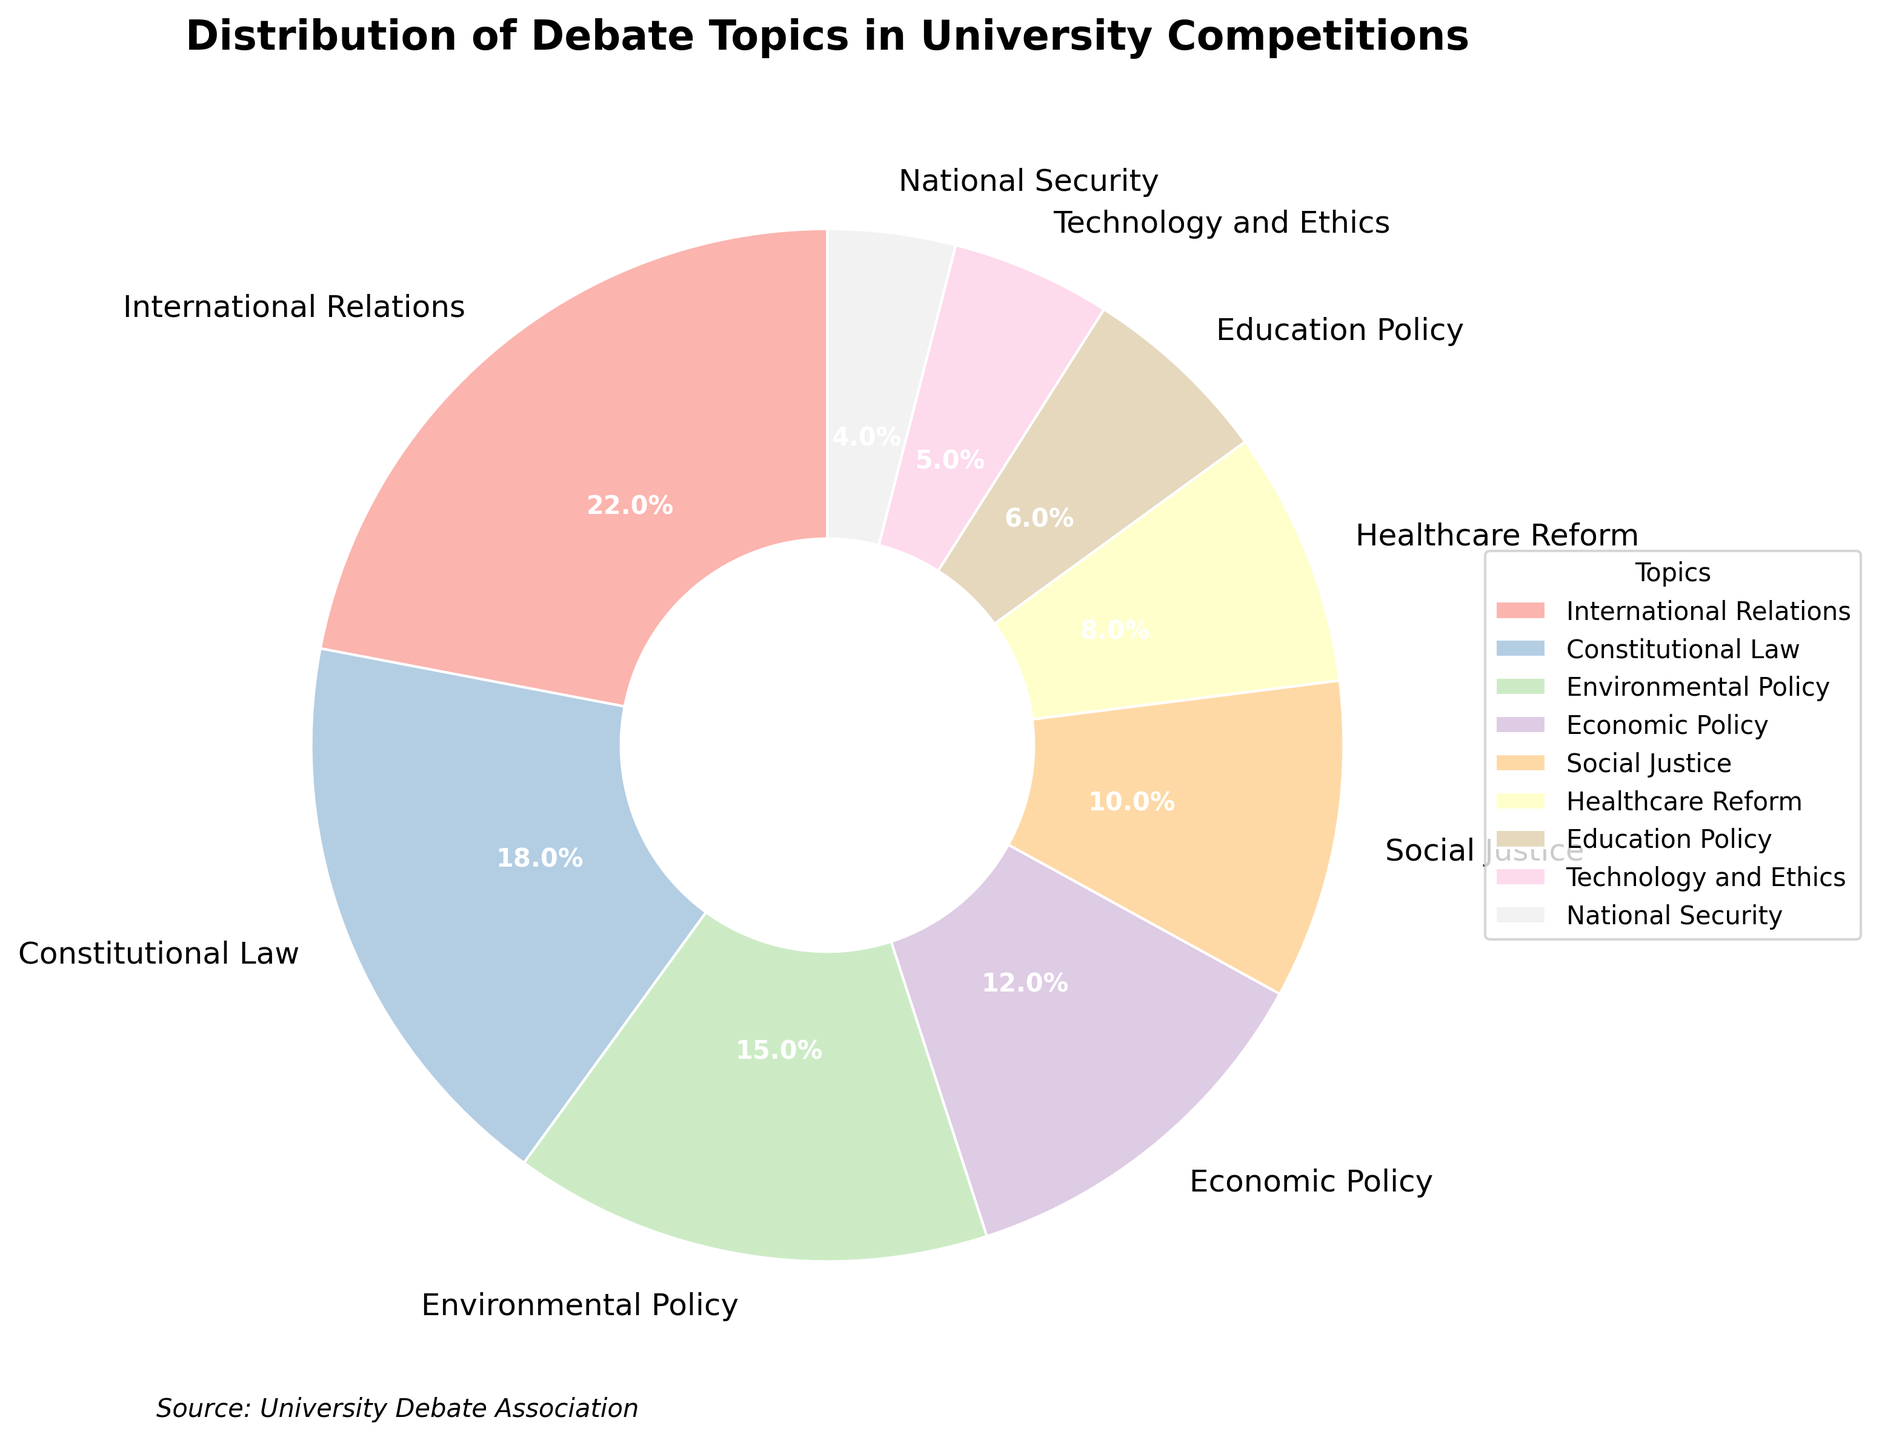What's the most common debate topic in university competitions? To find the most common topic, look for the one with the highest percentage. International Relations has 22%.
Answer: International Relations Which topic has a higher percentage, Economic Policy or Social Justice? Compare the percentages of both topics. Economic Policy has 12%, and Social Justice has 10%.
Answer: Economic Policy What is the combined percentage of topics related to policy (Economic Policy, Environmental Policy, and Education Policy)? Add the percentages of these topics: Economic Policy (12%), Environmental Policy (15%), and Education Policy (6%). 12 + 15 + 6 = 33%.
Answer: 33% What's the difference in percentage between International Relations and National Security? Subtract the percentage of National Security from International Relations. International Relations is 22%, and National Security is 4%. 22 - 4 = 18%.
Answer: 18% Which topics together make up more than 50% of the total? Determine the combination of topics whose combined percentage exceeds 50%. International Relations (22%) and Constitutional Law (18%) together make 40%. Adding Environmental Policy (15%) gives 55%.
Answer: International Relations, Constitutional Law, Environmental Policy What percentage of topics are not directly related to policy (excluding Economic, Environmental, and Education Policy)? Subtract the combined percentage of the policy-related topics from 100%. Policy topics are 33%. 100 - 33 = 67%.
Answer: 67% Which topic has the smallest percentage? Look for the topic with the lowest percentage in the chart. National Security has 4%.
Answer: National Security Are there more topics with a percentage greater than 10% or less than 10%? Count the topics with percentages above 10% and below 10%. Above 10%: 4 topics (International Relations, Constitutional Law, Environmental Policy, Economic Policy). Below 10%: 5 topics (Social Justice, Healthcare Reform, Education Policy, Technology and Ethics, National Security).
Answer: Less than 10% What's the average percentage of the topics related specifically to Social and Ethical issues (Social Justice and Technology and Ethics)? Add the percentages and divide by the number of topics. Social Justice (10%) and Technology and Ethics (5%). 10 + 5 = 15%, and 15 ÷ 2 = 7.5%.
Answer: 7.5% If a new topic was introduced with a percentage of 10%, how would this affect the rankings of the existing topics mentioned? Adding a 10% topic would shift all lower percentages down one rank. Social Justice, Healthcare Reform, Education Policy, Technology and Ethics, and National Security would all drop lower in rank to accommodate the new topic.
Answer: Social Justice and lower ranked topics would drop 